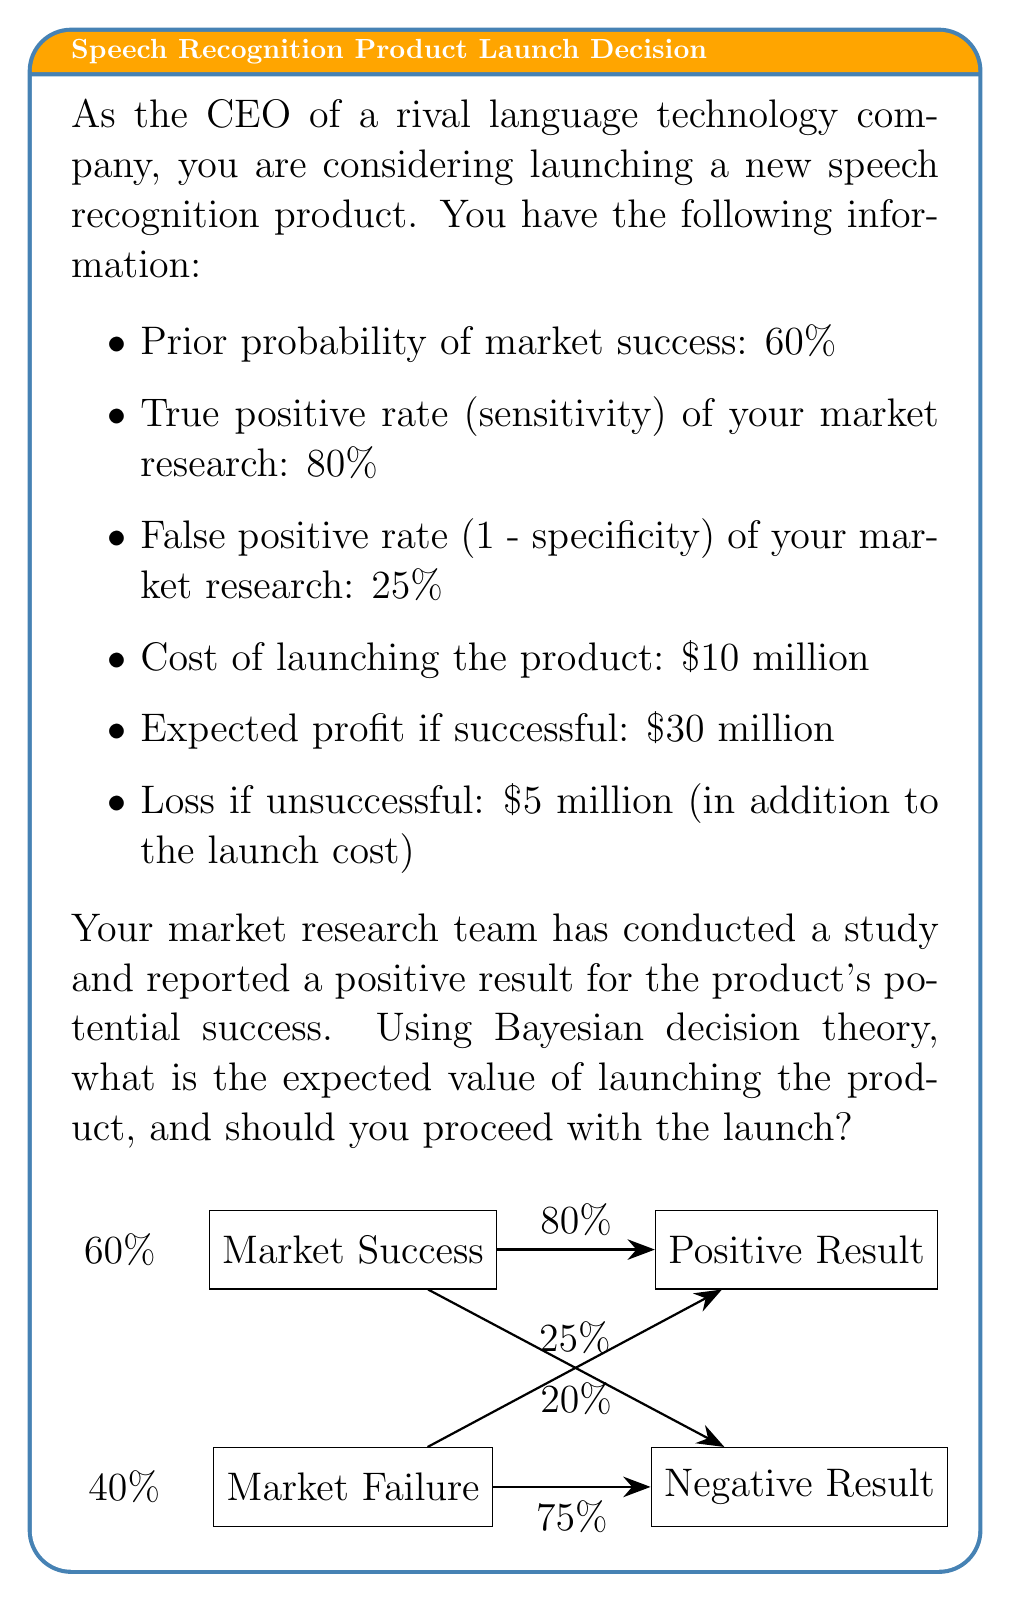Can you answer this question? Let's approach this problem step-by-step using Bayesian decision theory:

1) First, we need to calculate the posterior probability of market success given the positive result from the market research.

   Let A be the event of market success, and B be the event of a positive result.

   We can use Bayes' theorem:

   $$P(A|B) = \frac{P(B|A) \cdot P(A)}{P(B)}$$

   Where:
   $P(A) = 0.60$ (prior probability of success)
   $P(B|A) = 0.80$ (true positive rate)
   $P(B) = P(B|A) \cdot P(A) + P(B|\text{not }A) \cdot P(\text{not }A)$
         $= 0.80 \cdot 0.60 + 0.25 \cdot 0.40 = 0.58$

   Therefore:

   $$P(A|B) = \frac{0.80 \cdot 0.60}{0.58} \approx 0.8276$$

2) Now, let's calculate the expected value of launching the product:

   Success scenario: $0.8276 \cdot ($30 million - $10 million) = $16.552 million
   Failure scenario: $(1 - 0.8276) \cdot (-$10 million - $5 million) = -$2.586 million

   Expected Value = $16.552 million - $2.586 million = $13.966 million

3) Decision rule: Launch the product if the expected value is positive.

   Since the expected value ($13.966 million) is positive, you should proceed with the launch.
Answer: $13.966 million; launch the product 